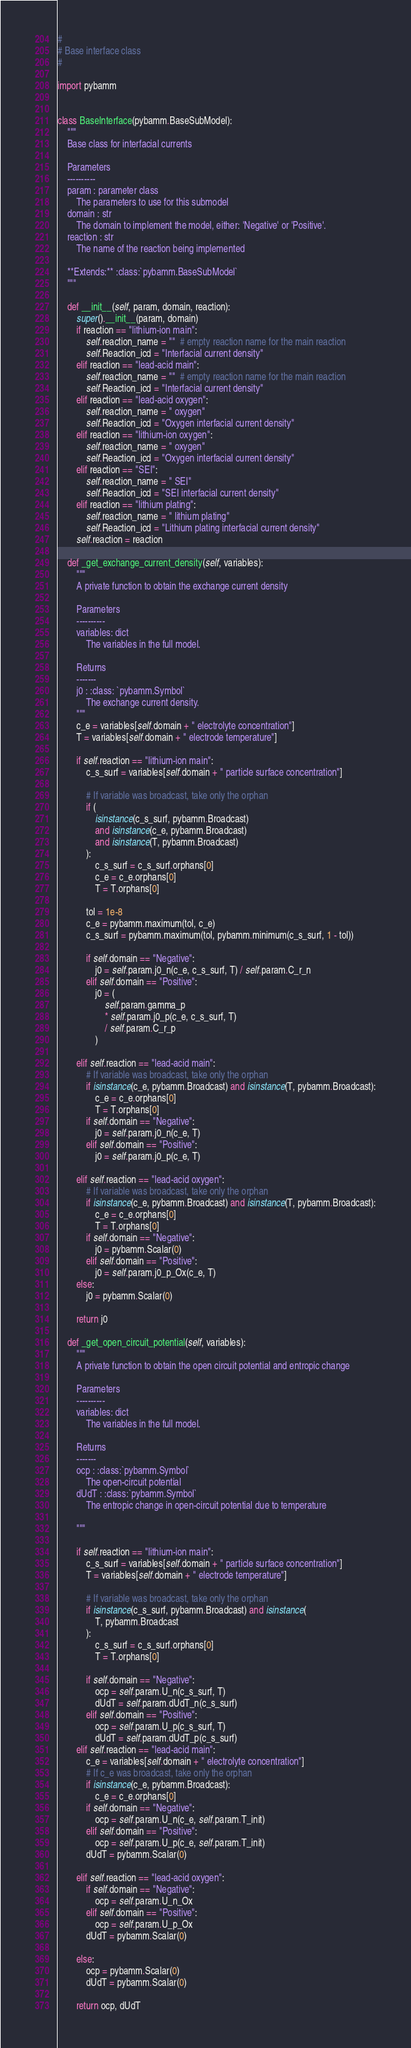<code> <loc_0><loc_0><loc_500><loc_500><_Python_>#
# Base interface class
#

import pybamm


class BaseInterface(pybamm.BaseSubModel):
    """
    Base class for interfacial currents

    Parameters
    ----------
    param : parameter class
        The parameters to use for this submodel
    domain : str
        The domain to implement the model, either: 'Negative' or 'Positive'.
    reaction : str
        The name of the reaction being implemented

    **Extends:** :class:`pybamm.BaseSubModel`
    """

    def __init__(self, param, domain, reaction):
        super().__init__(param, domain)
        if reaction == "lithium-ion main":
            self.reaction_name = ""  # empty reaction name for the main reaction
            self.Reaction_icd = "Interfacial current density"
        elif reaction == "lead-acid main":
            self.reaction_name = ""  # empty reaction name for the main reaction
            self.Reaction_icd = "Interfacial current density"
        elif reaction == "lead-acid oxygen":
            self.reaction_name = " oxygen"
            self.Reaction_icd = "Oxygen interfacial current density"
        elif reaction == "lithium-ion oxygen":
            self.reaction_name = " oxygen"
            self.Reaction_icd = "Oxygen interfacial current density"
        elif reaction == "SEI":
            self.reaction_name = " SEI"
            self.Reaction_icd = "SEI interfacial current density"
        elif reaction == "lithium plating":
            self.reaction_name = " lithium plating"
            self.Reaction_icd = "Lithium plating interfacial current density"
        self.reaction = reaction

    def _get_exchange_current_density(self, variables):
        """
        A private function to obtain the exchange current density

        Parameters
        ----------
        variables: dict
            The variables in the full model.

        Returns
        -------
        j0 : :class: `pybamm.Symbol`
            The exchange current density.
        """
        c_e = variables[self.domain + " electrolyte concentration"]
        T = variables[self.domain + " electrode temperature"]

        if self.reaction == "lithium-ion main":
            c_s_surf = variables[self.domain + " particle surface concentration"]

            # If variable was broadcast, take only the orphan
            if (
                isinstance(c_s_surf, pybamm.Broadcast)
                and isinstance(c_e, pybamm.Broadcast)
                and isinstance(T, pybamm.Broadcast)
            ):
                c_s_surf = c_s_surf.orphans[0]
                c_e = c_e.orphans[0]
                T = T.orphans[0]

            tol = 1e-8
            c_e = pybamm.maximum(tol, c_e)
            c_s_surf = pybamm.maximum(tol, pybamm.minimum(c_s_surf, 1 - tol))

            if self.domain == "Negative":
                j0 = self.param.j0_n(c_e, c_s_surf, T) / self.param.C_r_n
            elif self.domain == "Positive":
                j0 = (
                    self.param.gamma_p
                    * self.param.j0_p(c_e, c_s_surf, T)
                    / self.param.C_r_p
                )

        elif self.reaction == "lead-acid main":
            # If variable was broadcast, take only the orphan
            if isinstance(c_e, pybamm.Broadcast) and isinstance(T, pybamm.Broadcast):
                c_e = c_e.orphans[0]
                T = T.orphans[0]
            if self.domain == "Negative":
                j0 = self.param.j0_n(c_e, T)
            elif self.domain == "Positive":
                j0 = self.param.j0_p(c_e, T)

        elif self.reaction == "lead-acid oxygen":
            # If variable was broadcast, take only the orphan
            if isinstance(c_e, pybamm.Broadcast) and isinstance(T, pybamm.Broadcast):
                c_e = c_e.orphans[0]
                T = T.orphans[0]
            if self.domain == "Negative":
                j0 = pybamm.Scalar(0)
            elif self.domain == "Positive":
                j0 = self.param.j0_p_Ox(c_e, T)
        else:
            j0 = pybamm.Scalar(0)

        return j0

    def _get_open_circuit_potential(self, variables):
        """
        A private function to obtain the open circuit potential and entropic change

        Parameters
        ----------
        variables: dict
            The variables in the full model.

        Returns
        -------
        ocp : :class:`pybamm.Symbol`
            The open-circuit potential
        dUdT : :class:`pybamm.Symbol`
            The entropic change in open-circuit potential due to temperature

        """

        if self.reaction == "lithium-ion main":
            c_s_surf = variables[self.domain + " particle surface concentration"]
            T = variables[self.domain + " electrode temperature"]

            # If variable was broadcast, take only the orphan
            if isinstance(c_s_surf, pybamm.Broadcast) and isinstance(
                T, pybamm.Broadcast
            ):
                c_s_surf = c_s_surf.orphans[0]
                T = T.orphans[0]

            if self.domain == "Negative":
                ocp = self.param.U_n(c_s_surf, T)
                dUdT = self.param.dUdT_n(c_s_surf)
            elif self.domain == "Positive":
                ocp = self.param.U_p(c_s_surf, T)
                dUdT = self.param.dUdT_p(c_s_surf)
        elif self.reaction == "lead-acid main":
            c_e = variables[self.domain + " electrolyte concentration"]
            # If c_e was broadcast, take only the orphan
            if isinstance(c_e, pybamm.Broadcast):
                c_e = c_e.orphans[0]
            if self.domain == "Negative":
                ocp = self.param.U_n(c_e, self.param.T_init)
            elif self.domain == "Positive":
                ocp = self.param.U_p(c_e, self.param.T_init)
            dUdT = pybamm.Scalar(0)

        elif self.reaction == "lead-acid oxygen":
            if self.domain == "Negative":
                ocp = self.param.U_n_Ox
            elif self.domain == "Positive":
                ocp = self.param.U_p_Ox
            dUdT = pybamm.Scalar(0)

        else:
            ocp = pybamm.Scalar(0)
            dUdT = pybamm.Scalar(0)

        return ocp, dUdT
</code> 